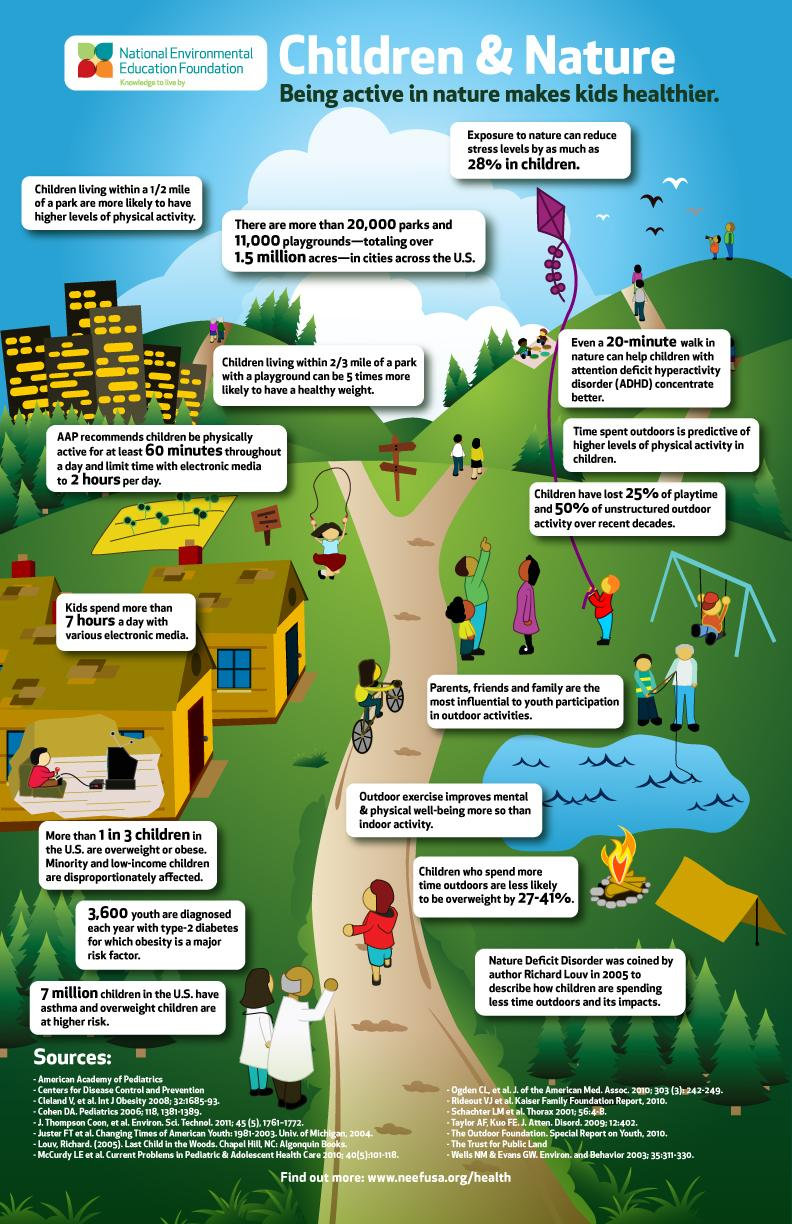Outline some significant characteristics in this image. The American Academy of Pediatrics recommends that children should not use electronic media for more than two hours per day. In the United States, approximately 33.33% of children are obese or overweight. According to the American Academy of Pediatrics (AAP), children spend an average of 5 hours more than the recommended amount of electronic media usage per day. The influence of parents, friends, and family on the participation of young people in outdoor activities is significant. 